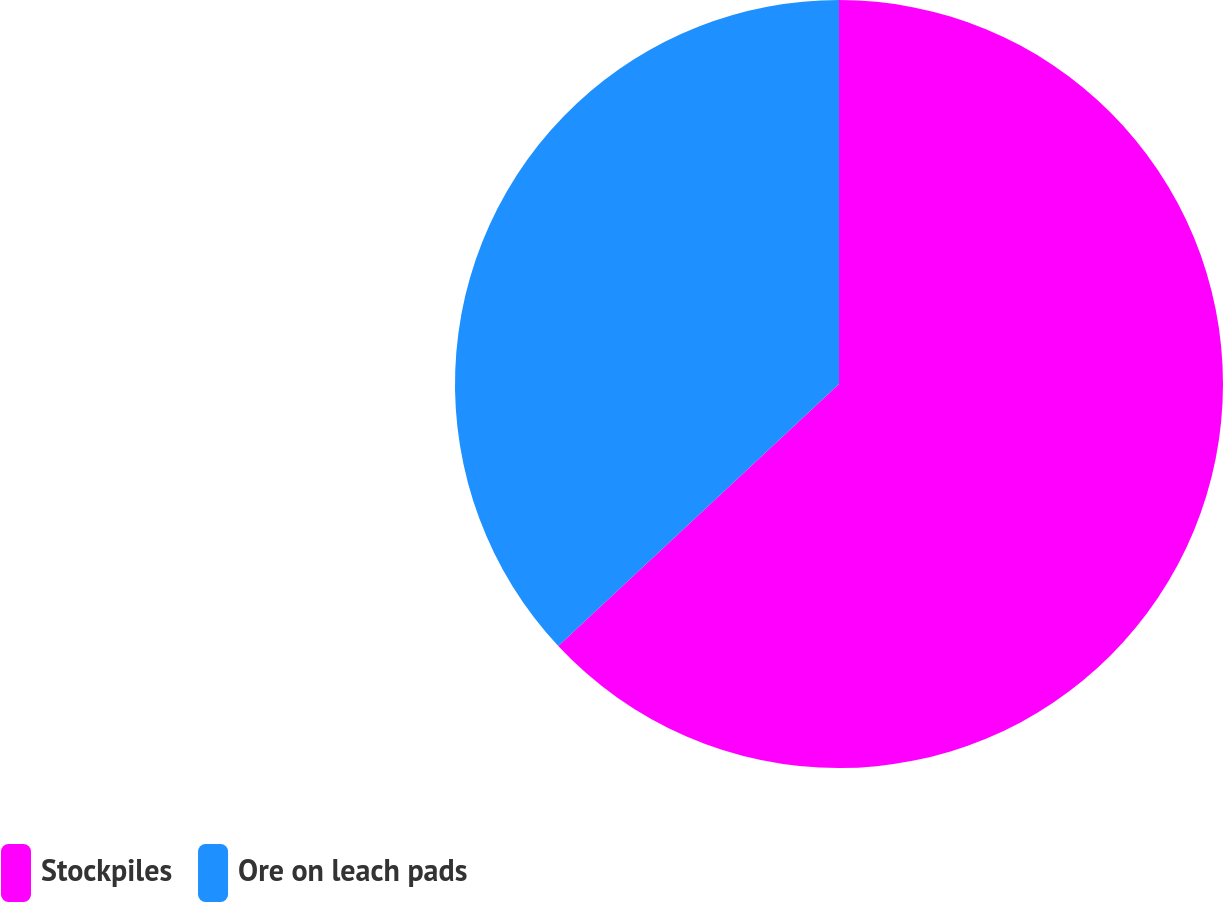<chart> <loc_0><loc_0><loc_500><loc_500><pie_chart><fcel>Stockpiles<fcel>Ore on leach pads<nl><fcel>63.05%<fcel>36.95%<nl></chart> 